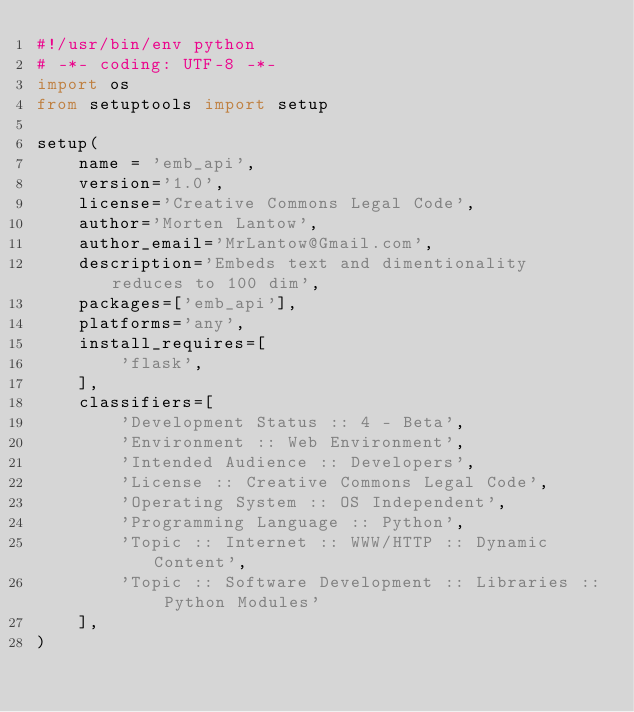<code> <loc_0><loc_0><loc_500><loc_500><_Python_>#!/usr/bin/env python
# -*- coding: UTF-8 -*-
import os
from setuptools import setup

setup(
    name = 'emb_api',
    version='1.0',
    license='Creative Commons Legal Code',
    author='Morten Lantow',
    author_email='MrLantow@Gmail.com',
    description='Embeds text and dimentionality reduces to 100 dim',
    packages=['emb_api'],
    platforms='any',
    install_requires=[
        'flask',
    ],
    classifiers=[
        'Development Status :: 4 - Beta',
        'Environment :: Web Environment',
        'Intended Audience :: Developers',
        'License :: Creative Commons Legal Code',
        'Operating System :: OS Independent',
        'Programming Language :: Python',
        'Topic :: Internet :: WWW/HTTP :: Dynamic Content',
        'Topic :: Software Development :: Libraries :: Python Modules'
    ],
)</code> 